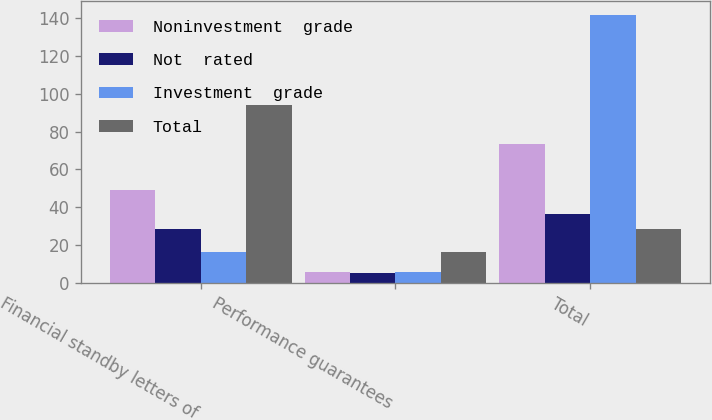<chart> <loc_0><loc_0><loc_500><loc_500><stacked_bar_chart><ecel><fcel>Financial standby letters of<fcel>Performance guarantees<fcel>Total<nl><fcel>Noninvestment  grade<fcel>49.2<fcel>5.7<fcel>73.4<nl><fcel>Not  rated<fcel>28.6<fcel>5<fcel>36.7<nl><fcel>Investment  grade<fcel>16.4<fcel>5.6<fcel>141.7<nl><fcel>Total<fcel>94.2<fcel>16.3<fcel>28.6<nl></chart> 